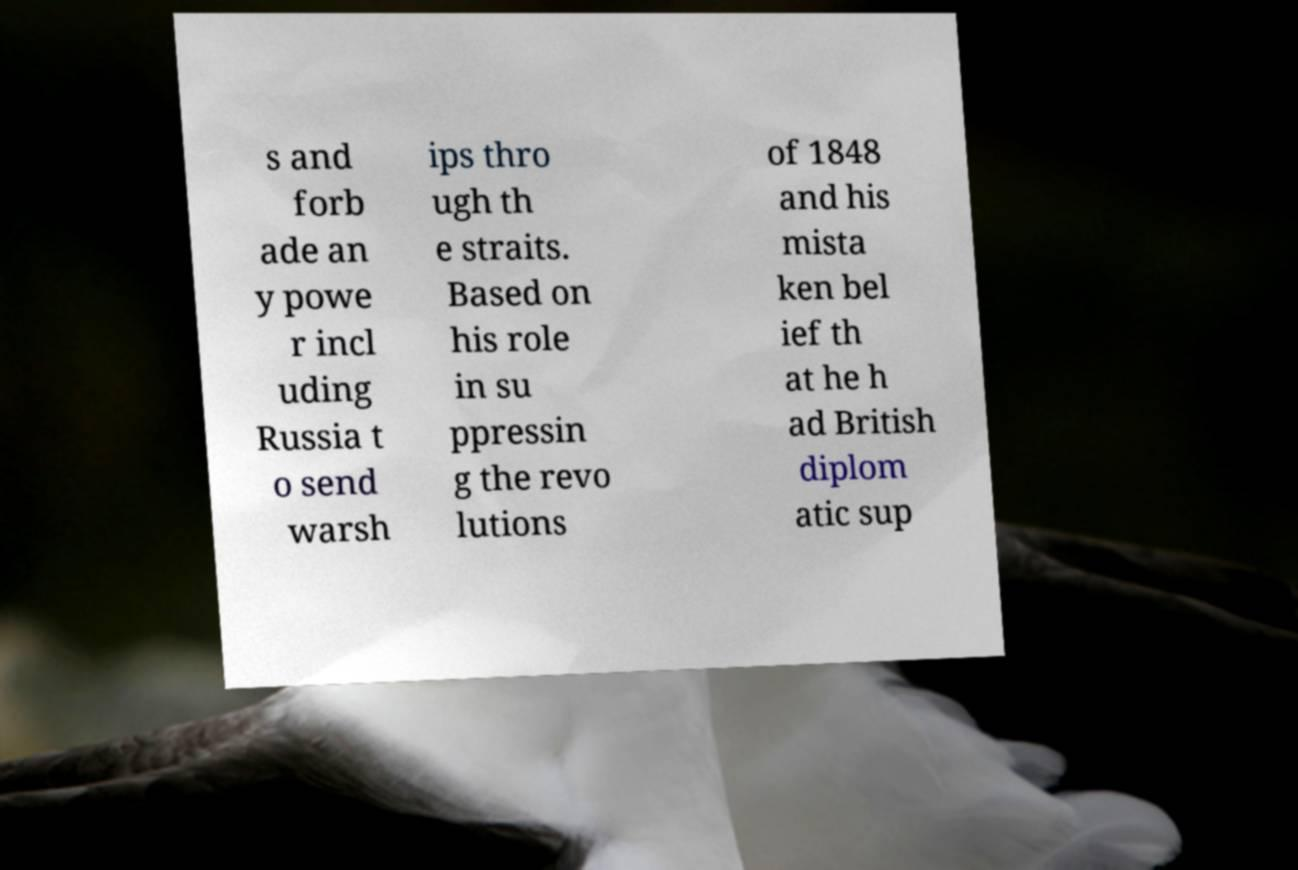For documentation purposes, I need the text within this image transcribed. Could you provide that? s and forb ade an y powe r incl uding Russia t o send warsh ips thro ugh th e straits. Based on his role in su ppressin g the revo lutions of 1848 and his mista ken bel ief th at he h ad British diplom atic sup 